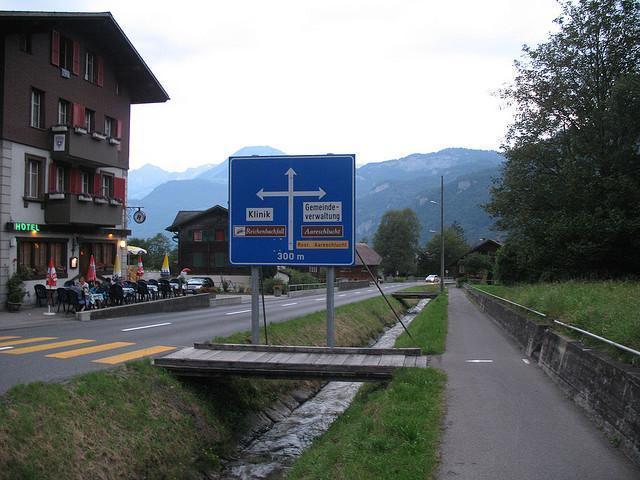How many laptop computers are within reaching distance of the woman sitting on the couch?
Give a very brief answer. 0. 